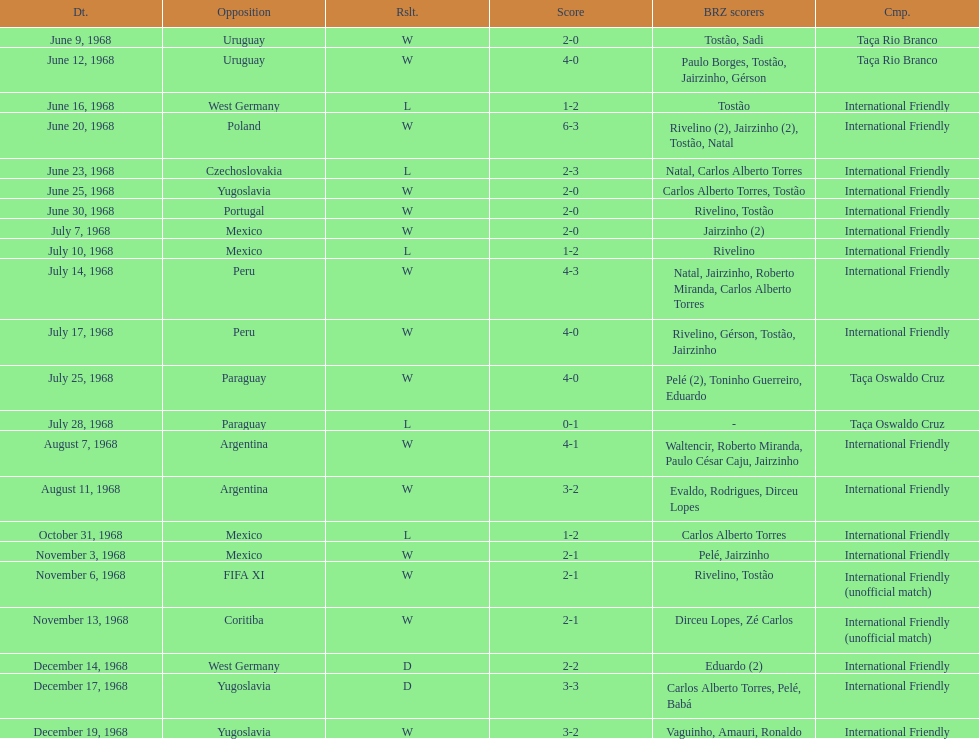How many matches are wins? 15. Can you give me this table as a dict? {'header': ['Dt.', 'Opposition', 'Rslt.', 'Score', 'BRZ scorers', 'Cmp.'], 'rows': [['June 9, 1968', 'Uruguay', 'W', '2-0', 'Tostão, Sadi', 'Taça Rio Branco'], ['June 12, 1968', 'Uruguay', 'W', '4-0', 'Paulo Borges, Tostão, Jairzinho, Gérson', 'Taça Rio Branco'], ['June 16, 1968', 'West Germany', 'L', '1-2', 'Tostão', 'International Friendly'], ['June 20, 1968', 'Poland', 'W', '6-3', 'Rivelino (2), Jairzinho (2), Tostão, Natal', 'International Friendly'], ['June 23, 1968', 'Czechoslovakia', 'L', '2-3', 'Natal, Carlos Alberto Torres', 'International Friendly'], ['June 25, 1968', 'Yugoslavia', 'W', '2-0', 'Carlos Alberto Torres, Tostão', 'International Friendly'], ['June 30, 1968', 'Portugal', 'W', '2-0', 'Rivelino, Tostão', 'International Friendly'], ['July 7, 1968', 'Mexico', 'W', '2-0', 'Jairzinho (2)', 'International Friendly'], ['July 10, 1968', 'Mexico', 'L', '1-2', 'Rivelino', 'International Friendly'], ['July 14, 1968', 'Peru', 'W', '4-3', 'Natal, Jairzinho, Roberto Miranda, Carlos Alberto Torres', 'International Friendly'], ['July 17, 1968', 'Peru', 'W', '4-0', 'Rivelino, Gérson, Tostão, Jairzinho', 'International Friendly'], ['July 25, 1968', 'Paraguay', 'W', '4-0', 'Pelé (2), Toninho Guerreiro, Eduardo', 'Taça Oswaldo Cruz'], ['July 28, 1968', 'Paraguay', 'L', '0-1', '-', 'Taça Oswaldo Cruz'], ['August 7, 1968', 'Argentina', 'W', '4-1', 'Waltencir, Roberto Miranda, Paulo César Caju, Jairzinho', 'International Friendly'], ['August 11, 1968', 'Argentina', 'W', '3-2', 'Evaldo, Rodrigues, Dirceu Lopes', 'International Friendly'], ['October 31, 1968', 'Mexico', 'L', '1-2', 'Carlos Alberto Torres', 'International Friendly'], ['November 3, 1968', 'Mexico', 'W', '2-1', 'Pelé, Jairzinho', 'International Friendly'], ['November 6, 1968', 'FIFA XI', 'W', '2-1', 'Rivelino, Tostão', 'International Friendly (unofficial match)'], ['November 13, 1968', 'Coritiba', 'W', '2-1', 'Dirceu Lopes, Zé Carlos', 'International Friendly (unofficial match)'], ['December 14, 1968', 'West Germany', 'D', '2-2', 'Eduardo (2)', 'International Friendly'], ['December 17, 1968', 'Yugoslavia', 'D', '3-3', 'Carlos Alberto Torres, Pelé, Babá', 'International Friendly'], ['December 19, 1968', 'Yugoslavia', 'W', '3-2', 'Vaguinho, Amauri, Ronaldo', 'International Friendly']]} 